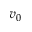<formula> <loc_0><loc_0><loc_500><loc_500>v _ { 0 }</formula> 